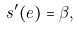Convert formula to latex. <formula><loc_0><loc_0><loc_500><loc_500>s ^ { \prime } ( e ) = \beta ,</formula> 